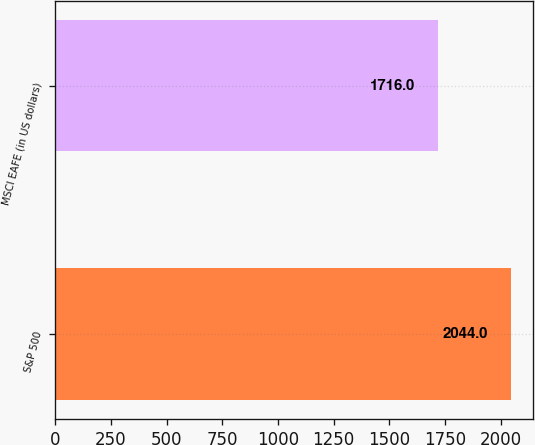<chart> <loc_0><loc_0><loc_500><loc_500><bar_chart><fcel>S&P 500<fcel>MSCI EAFE (in US dollars)<nl><fcel>2044<fcel>1716<nl></chart> 